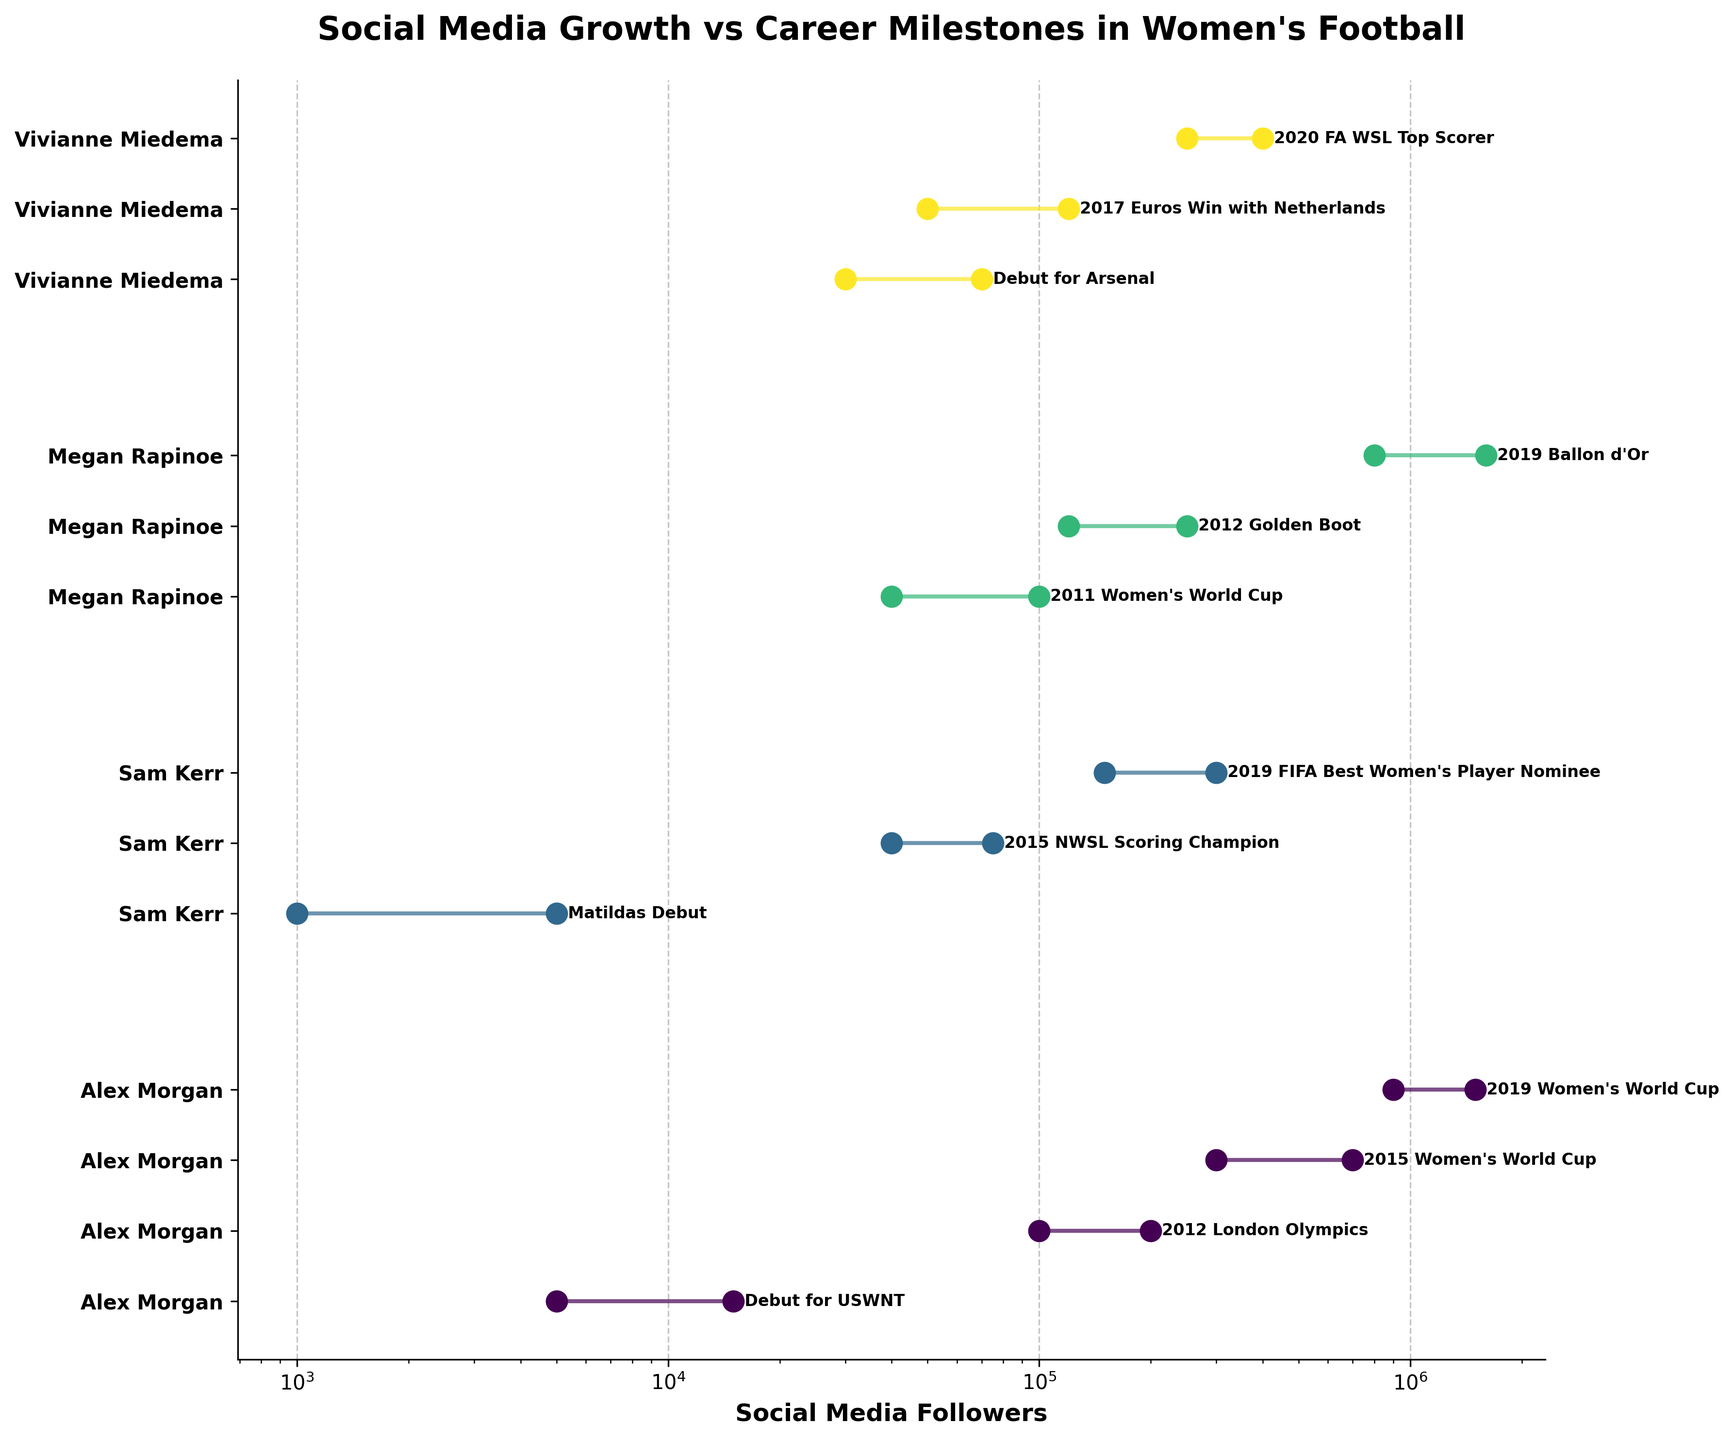How many players are represented in the figure? Identify the unique players presented by observing the unique color-coded dumbbells. Alex Morgan, Sam Kerr, Megan Rapinoe, and Vivianne Miedema are the players shown.
Answer: 4 Which player has the highest increase in followers during a single milestone? Look for the longest dumbbell line, indicating the largest range between start and end followers. Megan Rapinoe has a large increase during the 2019 Ballon d'Or milestone (800,000 to 1,600,000).
Answer: Megan Rapinoe What is the title of the figure? The title is displayed at the top of the figure, stating the main idea of the plot. It describes the key subject of the visualization, which is the social media growth in connection to career milestones for women's football players.
Answer: Social Media Growth vs Career Milestones in Women's Football Compare the social media growth of Alex Morgan and Sam Kerr during the 2015 Women's World Cup and the 2015 NWSL Scoring Champion milestones. Who had a greater increase? Calculate the difference in followers for both milestones: Alex Morgan (700,000 - 300,000 = 400,000) and Sam Kerr (75,000 - 40,000 = 35,000). Alex Morgan's increase is greater.
Answer: Alex Morgan Which milestones for Vivianne Miedema show an increase of over 100,000 followers? Observe the dumbbells for Vivianne Miedema and identify those with a start-to-end difference greater than 100,000. The milestones are: 2017 Euros Win with Netherlands (70,000) and 2020 FA WSL Top Scorer (150,000).
Answer: 2020 FA WSL Top Scorer How many milestones are displayed for Alex Morgan in total? Count the number of dumbbells or milestones labeled for Alex Morgan. There are four milestones shown.
Answer: 4 Which event for Sam Kerr led to the highest growth in followers? Compare the dumbbell lengths for Sam Kerr's milestones to see the one with the highest growth. The event is 2019 FIFA Best Women's Player Nominee where followers grew from 150,000 to 300,000.
Answer: 2019 FIFA Best Women's Player Nominee How does the figure highlight the differences in follower growth for various milestones? Examine the visual elements of the plot, noting how the horizontal lines (dumbbells) represent the change in followers and the circles highlight start and end values. Longer lines and larger differences in circle positions indicate greater growth.
Answer: Using dumbbells and circles What is the x-axis label shown in the figure? Look along the horizontal axis to identify the description provided, which indicates the measurement being shown (social media followers). It also mentions the scale type (logarithmic).
Answer: Social Media Followers What is the career milestone for Megan Rapinoe with the smallest follower increase shown? Identify the dumbbells for Megan Rapinoe and find the one with the smallest difference between start and end followers. The smallest increase is during the 2011 Women's World Cup (60,000).
Answer: 2011 Women's World Cup 